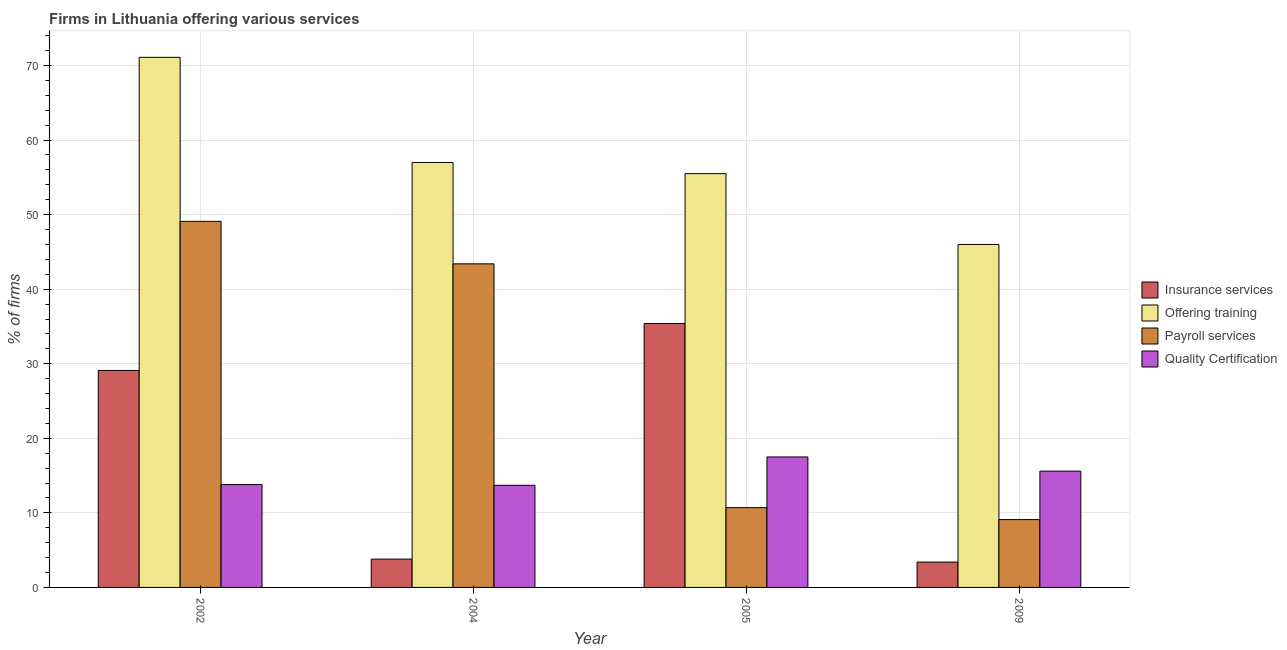How many different coloured bars are there?
Your response must be concise. 4. Are the number of bars per tick equal to the number of legend labels?
Your answer should be very brief. Yes. What is the percentage of firms offering payroll services in 2004?
Your response must be concise. 43.4. Across all years, what is the maximum percentage of firms offering payroll services?
Ensure brevity in your answer.  49.1. Across all years, what is the minimum percentage of firms offering payroll services?
Make the answer very short. 9.1. In which year was the percentage of firms offering training minimum?
Provide a short and direct response. 2009. What is the total percentage of firms offering insurance services in the graph?
Make the answer very short. 71.7. What is the difference between the percentage of firms offering payroll services in 2004 and that in 2005?
Keep it short and to the point. 32.7. What is the difference between the percentage of firms offering insurance services in 2005 and the percentage of firms offering training in 2004?
Your response must be concise. 31.6. What is the average percentage of firms offering training per year?
Your answer should be very brief. 57.4. What is the ratio of the percentage of firms offering quality certification in 2004 to that in 2005?
Keep it short and to the point. 0.78. Is the percentage of firms offering training in 2005 less than that in 2009?
Your response must be concise. No. What is the difference between the highest and the second highest percentage of firms offering insurance services?
Ensure brevity in your answer.  6.3. What is the difference between the highest and the lowest percentage of firms offering training?
Offer a very short reply. 25.1. Is the sum of the percentage of firms offering quality certification in 2002 and 2005 greater than the maximum percentage of firms offering insurance services across all years?
Provide a succinct answer. Yes. What does the 3rd bar from the left in 2002 represents?
Make the answer very short. Payroll services. What does the 2nd bar from the right in 2004 represents?
Offer a terse response. Payroll services. How many bars are there?
Your answer should be compact. 16. How many years are there in the graph?
Offer a very short reply. 4. Are the values on the major ticks of Y-axis written in scientific E-notation?
Keep it short and to the point. No. Where does the legend appear in the graph?
Your response must be concise. Center right. How are the legend labels stacked?
Offer a very short reply. Vertical. What is the title of the graph?
Make the answer very short. Firms in Lithuania offering various services . Does "Debt policy" appear as one of the legend labels in the graph?
Offer a terse response. No. What is the label or title of the Y-axis?
Your answer should be compact. % of firms. What is the % of firms in Insurance services in 2002?
Provide a short and direct response. 29.1. What is the % of firms in Offering training in 2002?
Give a very brief answer. 71.1. What is the % of firms in Payroll services in 2002?
Make the answer very short. 49.1. What is the % of firms of Offering training in 2004?
Provide a short and direct response. 57. What is the % of firms of Payroll services in 2004?
Make the answer very short. 43.4. What is the % of firms of Insurance services in 2005?
Offer a very short reply. 35.4. What is the % of firms of Offering training in 2005?
Your answer should be very brief. 55.5. What is the % of firms in Quality Certification in 2005?
Make the answer very short. 17.5. What is the % of firms in Payroll services in 2009?
Give a very brief answer. 9.1. What is the % of firms in Quality Certification in 2009?
Provide a succinct answer. 15.6. Across all years, what is the maximum % of firms of Insurance services?
Provide a succinct answer. 35.4. Across all years, what is the maximum % of firms in Offering training?
Your response must be concise. 71.1. Across all years, what is the maximum % of firms in Payroll services?
Offer a very short reply. 49.1. Across all years, what is the minimum % of firms of Payroll services?
Your response must be concise. 9.1. Across all years, what is the minimum % of firms in Quality Certification?
Keep it short and to the point. 13.7. What is the total % of firms of Insurance services in the graph?
Give a very brief answer. 71.7. What is the total % of firms in Offering training in the graph?
Ensure brevity in your answer.  229.6. What is the total % of firms of Payroll services in the graph?
Keep it short and to the point. 112.3. What is the total % of firms of Quality Certification in the graph?
Your answer should be compact. 60.6. What is the difference between the % of firms in Insurance services in 2002 and that in 2004?
Make the answer very short. 25.3. What is the difference between the % of firms in Payroll services in 2002 and that in 2004?
Provide a succinct answer. 5.7. What is the difference between the % of firms of Insurance services in 2002 and that in 2005?
Provide a short and direct response. -6.3. What is the difference between the % of firms of Offering training in 2002 and that in 2005?
Ensure brevity in your answer.  15.6. What is the difference between the % of firms in Payroll services in 2002 and that in 2005?
Offer a very short reply. 38.4. What is the difference between the % of firms of Insurance services in 2002 and that in 2009?
Ensure brevity in your answer.  25.7. What is the difference between the % of firms in Offering training in 2002 and that in 2009?
Offer a terse response. 25.1. What is the difference between the % of firms in Quality Certification in 2002 and that in 2009?
Provide a short and direct response. -1.8. What is the difference between the % of firms in Insurance services in 2004 and that in 2005?
Your answer should be compact. -31.6. What is the difference between the % of firms in Offering training in 2004 and that in 2005?
Make the answer very short. 1.5. What is the difference between the % of firms of Payroll services in 2004 and that in 2005?
Give a very brief answer. 32.7. What is the difference between the % of firms of Insurance services in 2004 and that in 2009?
Your answer should be compact. 0.4. What is the difference between the % of firms of Offering training in 2004 and that in 2009?
Provide a short and direct response. 11. What is the difference between the % of firms of Payroll services in 2004 and that in 2009?
Keep it short and to the point. 34.3. What is the difference between the % of firms in Insurance services in 2005 and that in 2009?
Offer a terse response. 32. What is the difference between the % of firms in Quality Certification in 2005 and that in 2009?
Provide a succinct answer. 1.9. What is the difference between the % of firms of Insurance services in 2002 and the % of firms of Offering training in 2004?
Keep it short and to the point. -27.9. What is the difference between the % of firms in Insurance services in 2002 and the % of firms in Payroll services in 2004?
Offer a terse response. -14.3. What is the difference between the % of firms in Offering training in 2002 and the % of firms in Payroll services in 2004?
Keep it short and to the point. 27.7. What is the difference between the % of firms in Offering training in 2002 and the % of firms in Quality Certification in 2004?
Your answer should be very brief. 57.4. What is the difference between the % of firms of Payroll services in 2002 and the % of firms of Quality Certification in 2004?
Offer a terse response. 35.4. What is the difference between the % of firms in Insurance services in 2002 and the % of firms in Offering training in 2005?
Ensure brevity in your answer.  -26.4. What is the difference between the % of firms in Offering training in 2002 and the % of firms in Payroll services in 2005?
Make the answer very short. 60.4. What is the difference between the % of firms in Offering training in 2002 and the % of firms in Quality Certification in 2005?
Offer a very short reply. 53.6. What is the difference between the % of firms in Payroll services in 2002 and the % of firms in Quality Certification in 2005?
Offer a terse response. 31.6. What is the difference between the % of firms in Insurance services in 2002 and the % of firms in Offering training in 2009?
Make the answer very short. -16.9. What is the difference between the % of firms of Insurance services in 2002 and the % of firms of Quality Certification in 2009?
Keep it short and to the point. 13.5. What is the difference between the % of firms in Offering training in 2002 and the % of firms in Quality Certification in 2009?
Keep it short and to the point. 55.5. What is the difference between the % of firms of Payroll services in 2002 and the % of firms of Quality Certification in 2009?
Make the answer very short. 33.5. What is the difference between the % of firms of Insurance services in 2004 and the % of firms of Offering training in 2005?
Provide a short and direct response. -51.7. What is the difference between the % of firms of Insurance services in 2004 and the % of firms of Quality Certification in 2005?
Your answer should be very brief. -13.7. What is the difference between the % of firms in Offering training in 2004 and the % of firms in Payroll services in 2005?
Provide a succinct answer. 46.3. What is the difference between the % of firms in Offering training in 2004 and the % of firms in Quality Certification in 2005?
Make the answer very short. 39.5. What is the difference between the % of firms of Payroll services in 2004 and the % of firms of Quality Certification in 2005?
Give a very brief answer. 25.9. What is the difference between the % of firms of Insurance services in 2004 and the % of firms of Offering training in 2009?
Provide a short and direct response. -42.2. What is the difference between the % of firms in Offering training in 2004 and the % of firms in Payroll services in 2009?
Make the answer very short. 47.9. What is the difference between the % of firms of Offering training in 2004 and the % of firms of Quality Certification in 2009?
Provide a short and direct response. 41.4. What is the difference between the % of firms in Payroll services in 2004 and the % of firms in Quality Certification in 2009?
Your response must be concise. 27.8. What is the difference between the % of firms in Insurance services in 2005 and the % of firms in Payroll services in 2009?
Your answer should be compact. 26.3. What is the difference between the % of firms of Insurance services in 2005 and the % of firms of Quality Certification in 2009?
Your response must be concise. 19.8. What is the difference between the % of firms in Offering training in 2005 and the % of firms in Payroll services in 2009?
Offer a very short reply. 46.4. What is the difference between the % of firms in Offering training in 2005 and the % of firms in Quality Certification in 2009?
Give a very brief answer. 39.9. What is the average % of firms in Insurance services per year?
Your response must be concise. 17.93. What is the average % of firms in Offering training per year?
Provide a succinct answer. 57.4. What is the average % of firms of Payroll services per year?
Give a very brief answer. 28.07. What is the average % of firms in Quality Certification per year?
Offer a very short reply. 15.15. In the year 2002, what is the difference between the % of firms in Insurance services and % of firms in Offering training?
Provide a short and direct response. -42. In the year 2002, what is the difference between the % of firms in Insurance services and % of firms in Payroll services?
Provide a succinct answer. -20. In the year 2002, what is the difference between the % of firms of Insurance services and % of firms of Quality Certification?
Provide a short and direct response. 15.3. In the year 2002, what is the difference between the % of firms of Offering training and % of firms of Payroll services?
Give a very brief answer. 22. In the year 2002, what is the difference between the % of firms in Offering training and % of firms in Quality Certification?
Make the answer very short. 57.3. In the year 2002, what is the difference between the % of firms of Payroll services and % of firms of Quality Certification?
Your answer should be compact. 35.3. In the year 2004, what is the difference between the % of firms of Insurance services and % of firms of Offering training?
Give a very brief answer. -53.2. In the year 2004, what is the difference between the % of firms in Insurance services and % of firms in Payroll services?
Give a very brief answer. -39.6. In the year 2004, what is the difference between the % of firms of Offering training and % of firms of Payroll services?
Give a very brief answer. 13.6. In the year 2004, what is the difference between the % of firms of Offering training and % of firms of Quality Certification?
Offer a very short reply. 43.3. In the year 2004, what is the difference between the % of firms in Payroll services and % of firms in Quality Certification?
Your answer should be very brief. 29.7. In the year 2005, what is the difference between the % of firms of Insurance services and % of firms of Offering training?
Provide a short and direct response. -20.1. In the year 2005, what is the difference between the % of firms in Insurance services and % of firms in Payroll services?
Give a very brief answer. 24.7. In the year 2005, what is the difference between the % of firms in Insurance services and % of firms in Quality Certification?
Your answer should be very brief. 17.9. In the year 2005, what is the difference between the % of firms of Offering training and % of firms of Payroll services?
Your answer should be very brief. 44.8. In the year 2005, what is the difference between the % of firms of Offering training and % of firms of Quality Certification?
Your answer should be very brief. 38. In the year 2005, what is the difference between the % of firms in Payroll services and % of firms in Quality Certification?
Ensure brevity in your answer.  -6.8. In the year 2009, what is the difference between the % of firms in Insurance services and % of firms in Offering training?
Ensure brevity in your answer.  -42.6. In the year 2009, what is the difference between the % of firms in Insurance services and % of firms in Payroll services?
Your answer should be compact. -5.7. In the year 2009, what is the difference between the % of firms in Offering training and % of firms in Payroll services?
Give a very brief answer. 36.9. In the year 2009, what is the difference between the % of firms in Offering training and % of firms in Quality Certification?
Ensure brevity in your answer.  30.4. In the year 2009, what is the difference between the % of firms in Payroll services and % of firms in Quality Certification?
Give a very brief answer. -6.5. What is the ratio of the % of firms in Insurance services in 2002 to that in 2004?
Offer a very short reply. 7.66. What is the ratio of the % of firms in Offering training in 2002 to that in 2004?
Your answer should be very brief. 1.25. What is the ratio of the % of firms in Payroll services in 2002 to that in 2004?
Your response must be concise. 1.13. What is the ratio of the % of firms in Quality Certification in 2002 to that in 2004?
Your response must be concise. 1.01. What is the ratio of the % of firms of Insurance services in 2002 to that in 2005?
Provide a succinct answer. 0.82. What is the ratio of the % of firms in Offering training in 2002 to that in 2005?
Keep it short and to the point. 1.28. What is the ratio of the % of firms of Payroll services in 2002 to that in 2005?
Keep it short and to the point. 4.59. What is the ratio of the % of firms of Quality Certification in 2002 to that in 2005?
Your answer should be very brief. 0.79. What is the ratio of the % of firms in Insurance services in 2002 to that in 2009?
Offer a terse response. 8.56. What is the ratio of the % of firms in Offering training in 2002 to that in 2009?
Make the answer very short. 1.55. What is the ratio of the % of firms of Payroll services in 2002 to that in 2009?
Give a very brief answer. 5.4. What is the ratio of the % of firms in Quality Certification in 2002 to that in 2009?
Give a very brief answer. 0.88. What is the ratio of the % of firms of Insurance services in 2004 to that in 2005?
Offer a terse response. 0.11. What is the ratio of the % of firms of Offering training in 2004 to that in 2005?
Keep it short and to the point. 1.03. What is the ratio of the % of firms of Payroll services in 2004 to that in 2005?
Make the answer very short. 4.06. What is the ratio of the % of firms in Quality Certification in 2004 to that in 2005?
Ensure brevity in your answer.  0.78. What is the ratio of the % of firms of Insurance services in 2004 to that in 2009?
Keep it short and to the point. 1.12. What is the ratio of the % of firms in Offering training in 2004 to that in 2009?
Keep it short and to the point. 1.24. What is the ratio of the % of firms of Payroll services in 2004 to that in 2009?
Offer a very short reply. 4.77. What is the ratio of the % of firms of Quality Certification in 2004 to that in 2009?
Make the answer very short. 0.88. What is the ratio of the % of firms in Insurance services in 2005 to that in 2009?
Your answer should be compact. 10.41. What is the ratio of the % of firms in Offering training in 2005 to that in 2009?
Offer a very short reply. 1.21. What is the ratio of the % of firms in Payroll services in 2005 to that in 2009?
Your response must be concise. 1.18. What is the ratio of the % of firms in Quality Certification in 2005 to that in 2009?
Provide a succinct answer. 1.12. What is the difference between the highest and the second highest % of firms of Insurance services?
Provide a succinct answer. 6.3. What is the difference between the highest and the second highest % of firms in Quality Certification?
Your answer should be very brief. 1.9. What is the difference between the highest and the lowest % of firms of Offering training?
Make the answer very short. 25.1. What is the difference between the highest and the lowest % of firms in Quality Certification?
Offer a very short reply. 3.8. 